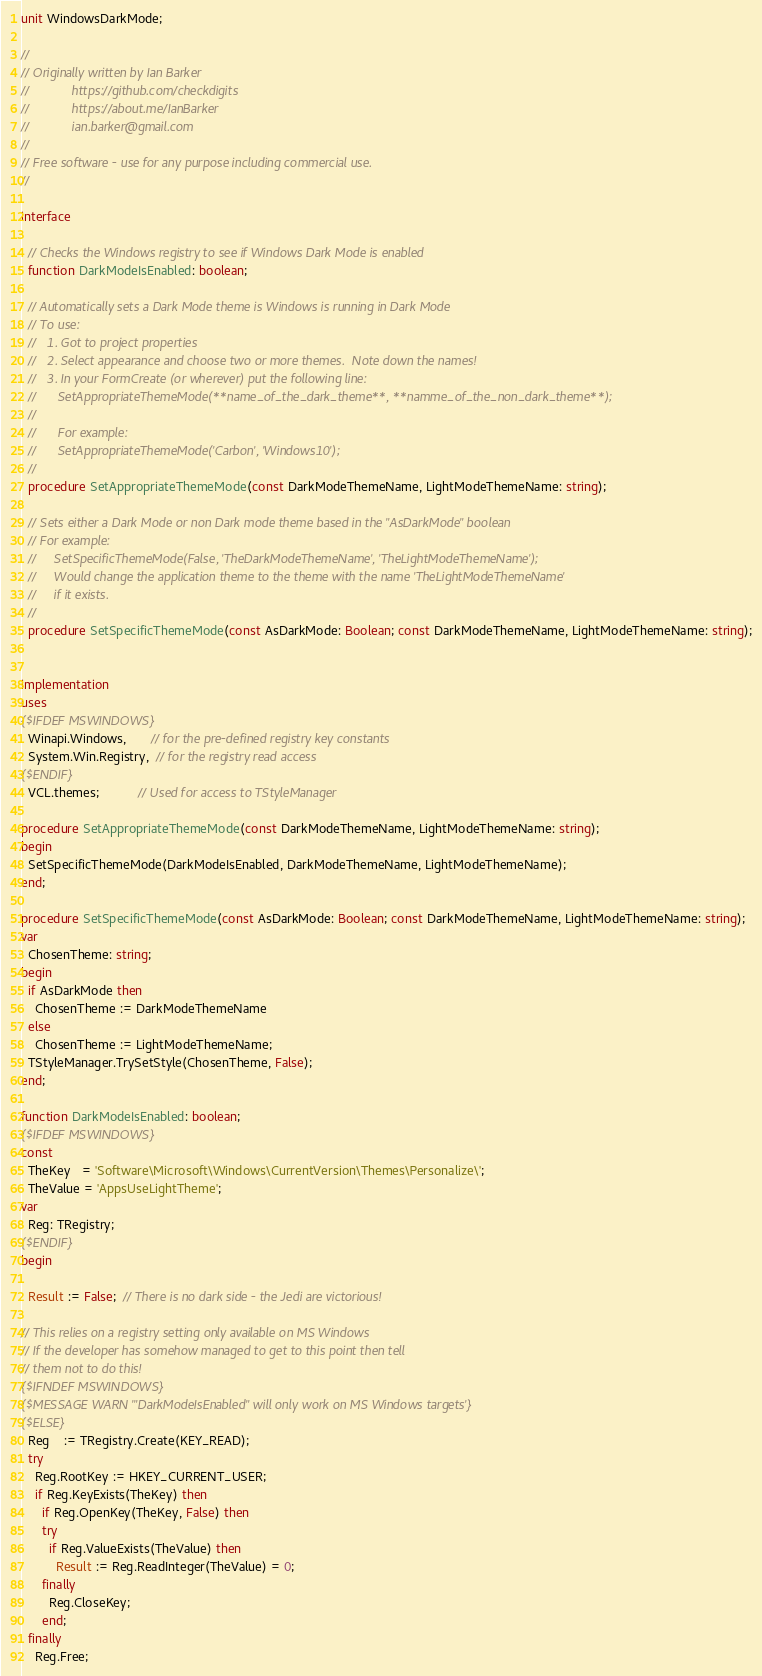Convert code to text. <code><loc_0><loc_0><loc_500><loc_500><_Pascal_>unit WindowsDarkMode;

//
// Originally written by Ian Barker
//            https://github.com/checkdigits
//            https://about.me/IanBarker
//            ian.barker@gmail.com
//
// Free software - use for any purpose including commercial use.
//

interface

  // Checks the Windows registry to see if Windows Dark Mode is enabled
  function DarkModeIsEnabled: boolean;

  // Automatically sets a Dark Mode theme is Windows is running in Dark Mode
  // To use:
  //   1. Got to project properties
  //   2. Select appearance and choose two or more themes.  Note down the names!
  //   3. In your FormCreate (or wherever) put the following line:
  //      SetAppropriateThemeMode(**name_of_the_dark_theme**, **namme_of_the_non_dark_theme**);
  //
  //      For example:
  //      SetAppropriateThemeMode('Carbon', 'Windows10');
  //
  procedure SetAppropriateThemeMode(const DarkModeThemeName, LightModeThemeName: string);

  // Sets either a Dark Mode or non Dark mode theme based in the "AsDarkMode" boolean
  // For example:
  //     SetSpecificThemeMode(False, 'TheDarkModeThemeName', 'TheLightModeThemeName');
  //     Would change the application theme to the theme with the name 'TheLightModeThemeName'
  //     if it exists.
  //
  procedure SetSpecificThemeMode(const AsDarkMode: Boolean; const DarkModeThemeName, LightModeThemeName: string);


implementation
uses
{$IFDEF MSWINDOWS}
  Winapi.Windows,       // for the pre-defined registry key constants
  System.Win.Registry,  // for the registry read access
{$ENDIF}
  VCL.themes;           // Used for access to TStyleManager

procedure SetAppropriateThemeMode(const DarkModeThemeName, LightModeThemeName: string);
begin
  SetSpecificThemeMode(DarkModeIsEnabled, DarkModeThemeName, LightModeThemeName);
end;

procedure SetSpecificThemeMode(const AsDarkMode: Boolean; const DarkModeThemeName, LightModeThemeName: string);
var
  ChosenTheme: string;
begin
  if AsDarkMode then
    ChosenTheme := DarkModeThemeName
  else
    ChosenTheme := LightModeThemeName;
  TStyleManager.TrySetStyle(ChosenTheme, False);
end;

function DarkModeIsEnabled: boolean;
{$IFDEF MSWINDOWS}
const
  TheKey   = 'Software\Microsoft\Windows\CurrentVersion\Themes\Personalize\';
  TheValue = 'AppsUseLightTheme';
var
  Reg: TRegistry;
{$ENDIF}
begin

  Result := False;  // There is no dark side - the Jedi are victorious!

// This relies on a registry setting only available on MS Windows
// If the developer has somehow managed to get to this point then tell
// them not to do this!
{$IFNDEF MSWINDOWS}
{$MESSAGE WARN '"DarkModeIsEnabled" will only work on MS Windows targets'}
{$ELSE}
  Reg    := TRegistry.Create(KEY_READ);
  try
    Reg.RootKey := HKEY_CURRENT_USER;
    if Reg.KeyExists(TheKey) then
      if Reg.OpenKey(TheKey, False) then
      try
        if Reg.ValueExists(TheValue) then
          Result := Reg.ReadInteger(TheValue) = 0;
      finally
        Reg.CloseKey;
      end;
  finally
    Reg.Free;</code> 